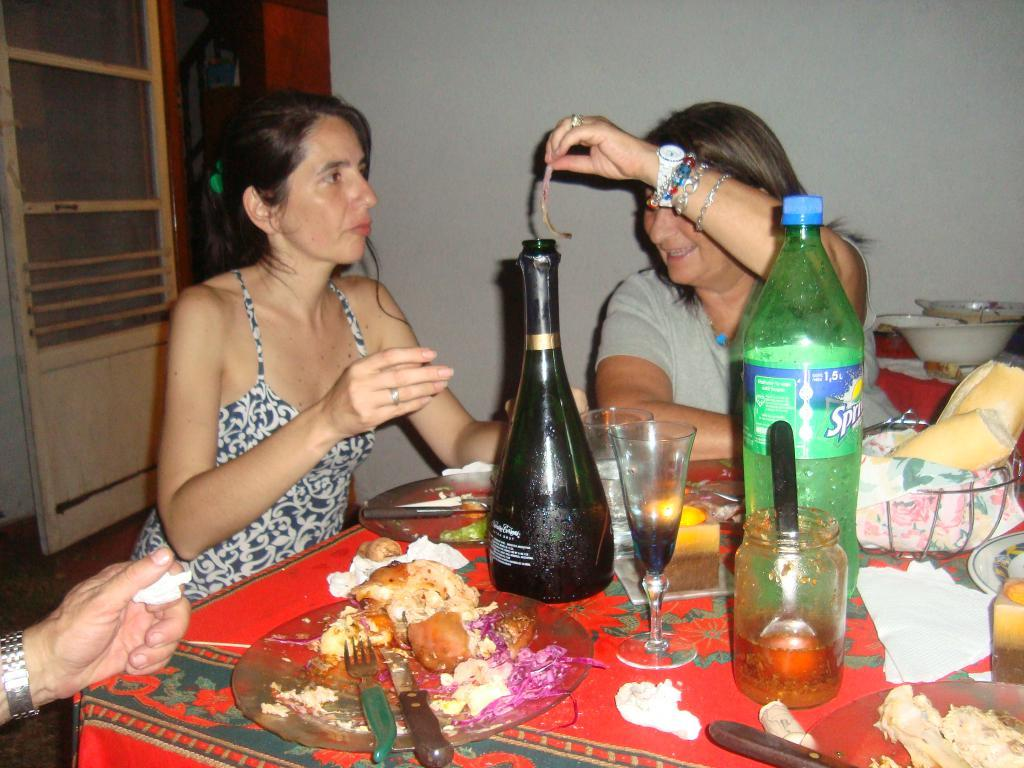<image>
Share a concise interpretation of the image provided. One woman holds something for another woman to see while they are seated at a table that has food and a large bottle of Sprite on it. 